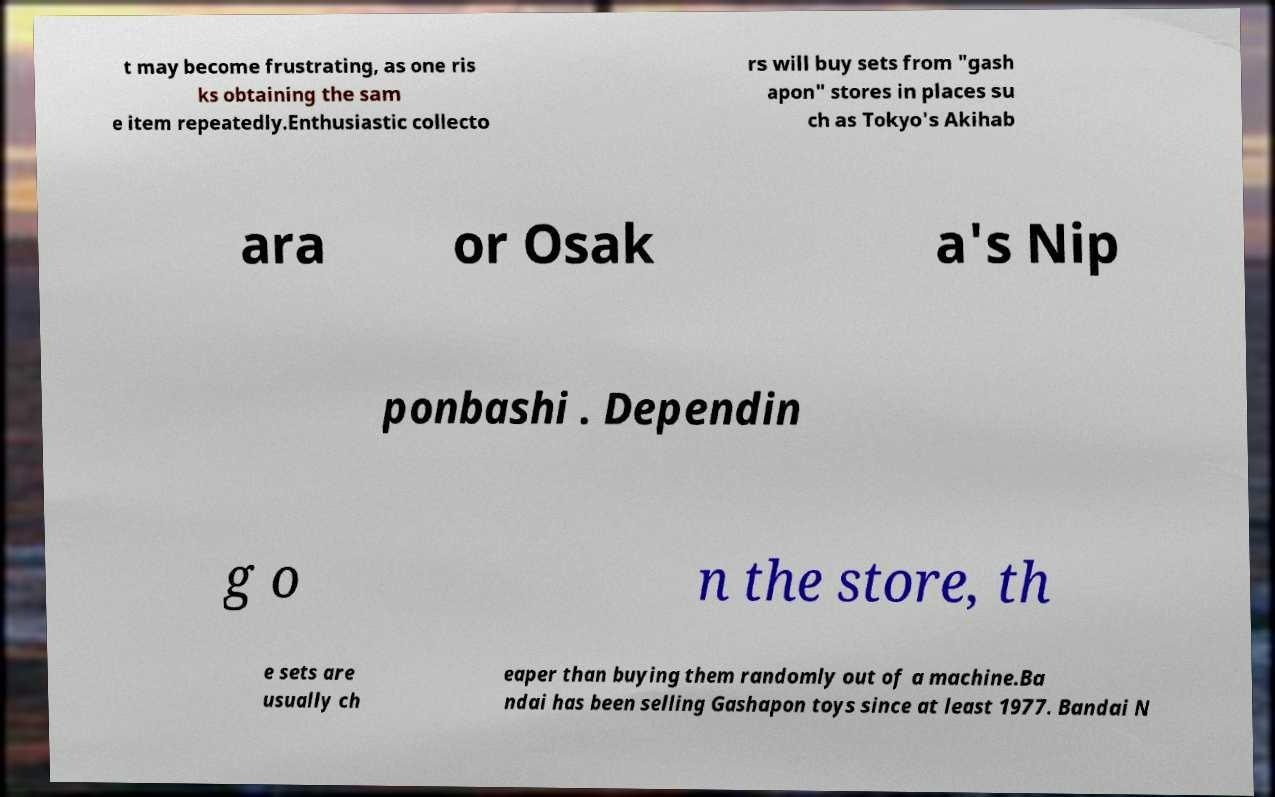Can you read and provide the text displayed in the image?This photo seems to have some interesting text. Can you extract and type it out for me? t may become frustrating, as one ris ks obtaining the sam e item repeatedly.Enthusiastic collecto rs will buy sets from "gash apon" stores in places su ch as Tokyo's Akihab ara or Osak a's Nip ponbashi . Dependin g o n the store, th e sets are usually ch eaper than buying them randomly out of a machine.Ba ndai has been selling Gashapon toys since at least 1977. Bandai N 